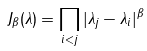Convert formula to latex. <formula><loc_0><loc_0><loc_500><loc_500>J _ { \beta } ( \lambda ) = \prod _ { i < j } | \lambda _ { j } - \lambda _ { i } | ^ { \beta }</formula> 